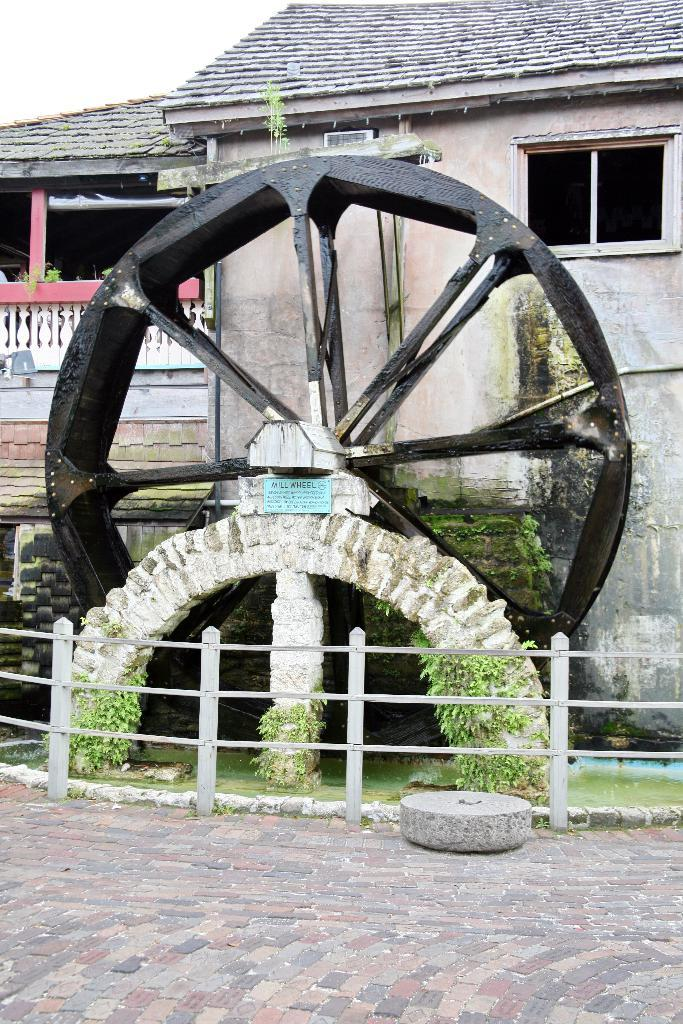What is the main object depicted in the image? There is a depiction of a wheel in the image. What structure can be seen behind the wheel? There is a house visible behind the wheel. What is located at the bottom of the image? There is a fence and plants at the bottom of the image, as well as a path. How many balls are being divided in the argument in the image? There are no balls or arguments present in the image; it features a wheel, a house, a fence, plants, and a path. 